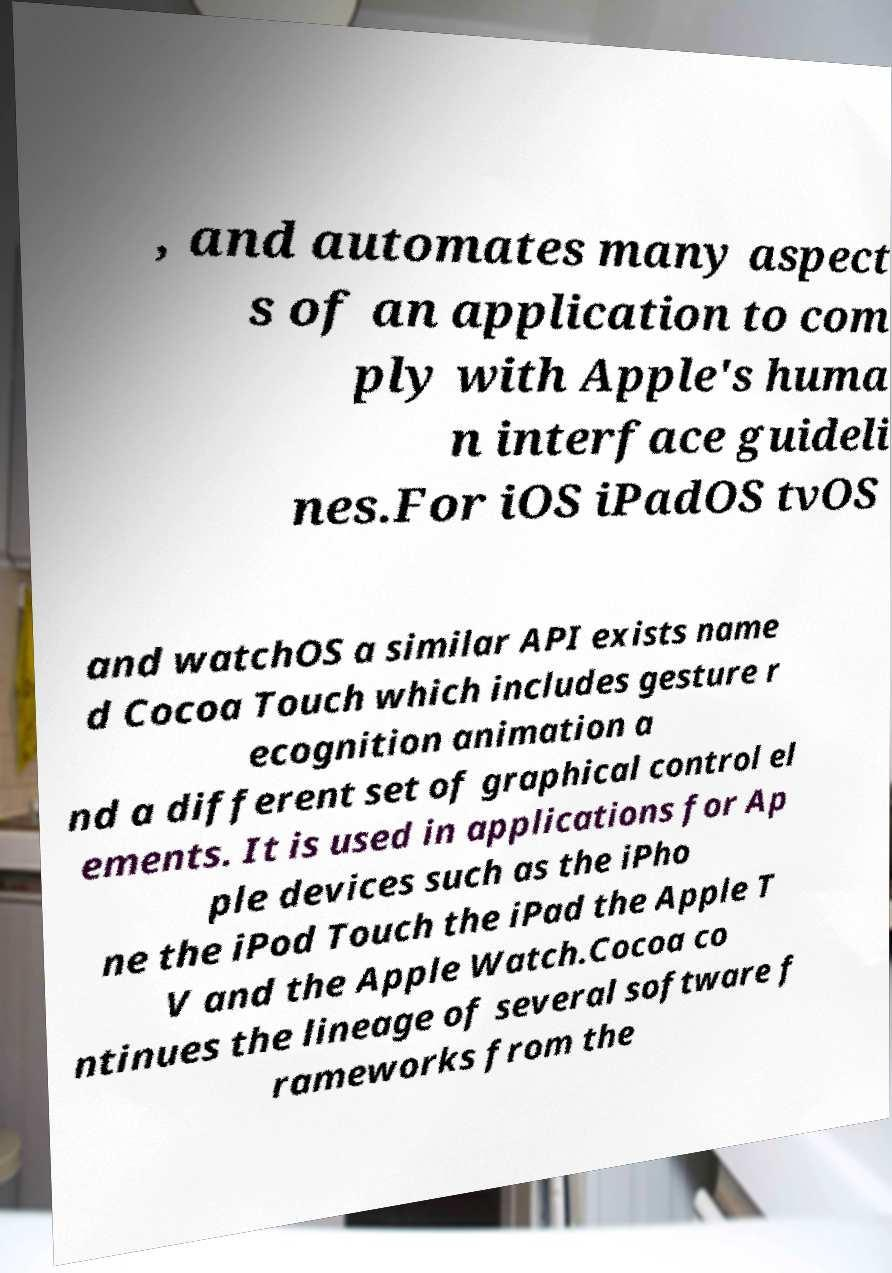There's text embedded in this image that I need extracted. Can you transcribe it verbatim? , and automates many aspect s of an application to com ply with Apple's huma n interface guideli nes.For iOS iPadOS tvOS and watchOS a similar API exists name d Cocoa Touch which includes gesture r ecognition animation a nd a different set of graphical control el ements. It is used in applications for Ap ple devices such as the iPho ne the iPod Touch the iPad the Apple T V and the Apple Watch.Cocoa co ntinues the lineage of several software f rameworks from the 